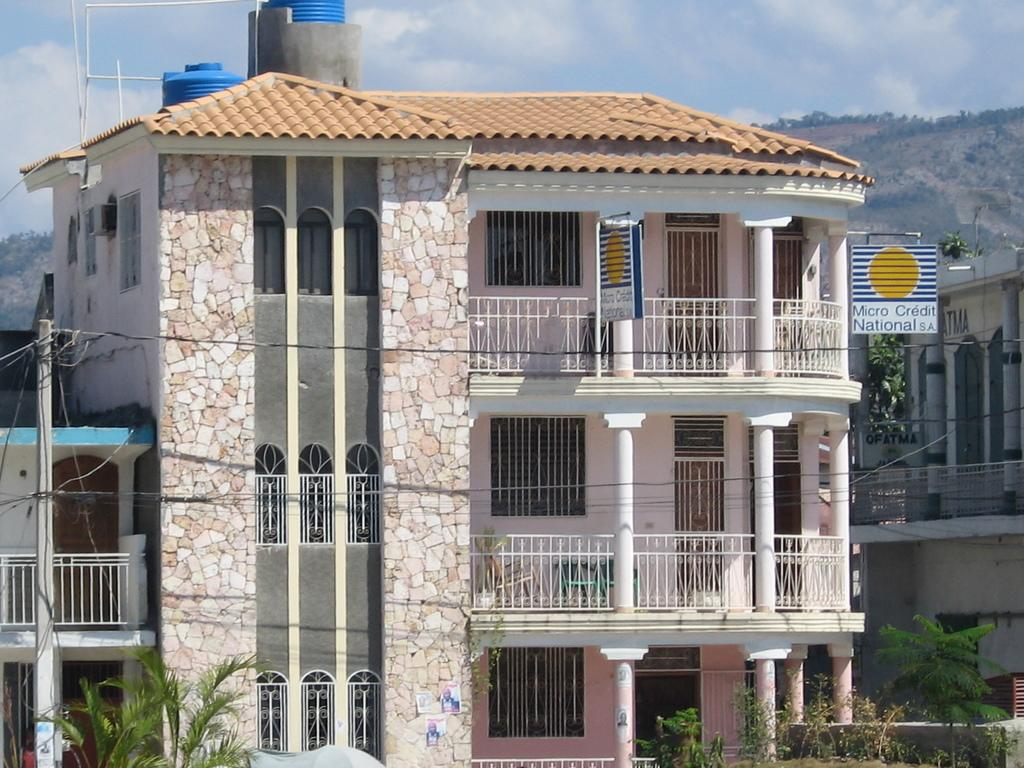What is the size of the building in the image? The building in the image is very big. What can be seen on the building? There are water tanks in blue color on the building. What type of vegetation is at the bottom of the image? There are trees at the bottom of the image. What is visible at the top of the image? The sky is blue and visible at the top of the image. What type of pleasure can be seen in the image? There is no indication of pleasure in the image; it features a big building with water tanks, trees, and a blue sky. Can you identify the judge in the image? There is no judge present in the image. 